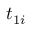<formula> <loc_0><loc_0><loc_500><loc_500>t _ { 1 i }</formula> 